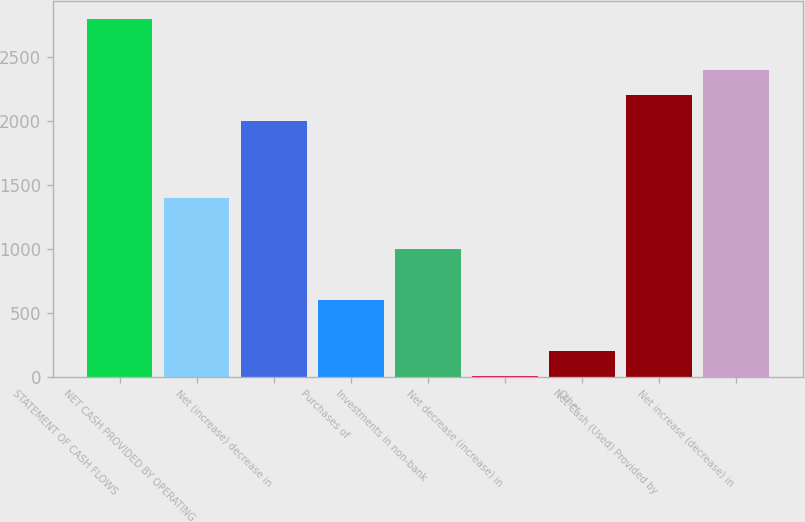Convert chart. <chart><loc_0><loc_0><loc_500><loc_500><bar_chart><fcel>STATEMENT OF CASH FLOWS<fcel>NET CASH PROVIDED BY OPERATING<fcel>Net (increase) decrease in<fcel>Purchases of<fcel>Investments in non-bank<fcel>Net decrease (increase) in<fcel>Other<fcel>Net Cash (Used) Provided by<fcel>Net increase (decrease) in<nl><fcel>2801<fcel>1401<fcel>2001<fcel>601<fcel>1001<fcel>1<fcel>201<fcel>2201<fcel>2401<nl></chart> 